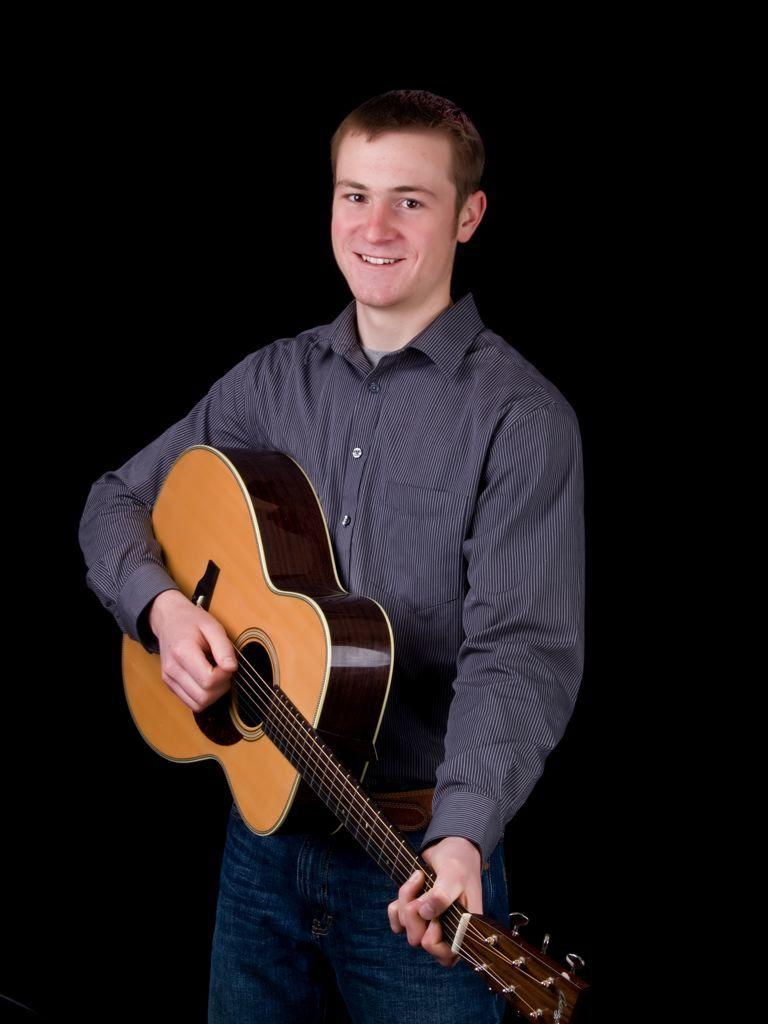Who is present in the image? There is a man in the image. What is the man doing in the image? The man is standing in the image. What object is the man holding in the image? The man is holding a guitar in his hand. What is the man's facial expression in the image? The man has a smiling face in the image. What type of bee can be seen buzzing around the man's head in the image? There is no bee present in the image. Can you describe the yak that is standing next to the man in the image? There is no yak present in the image. 